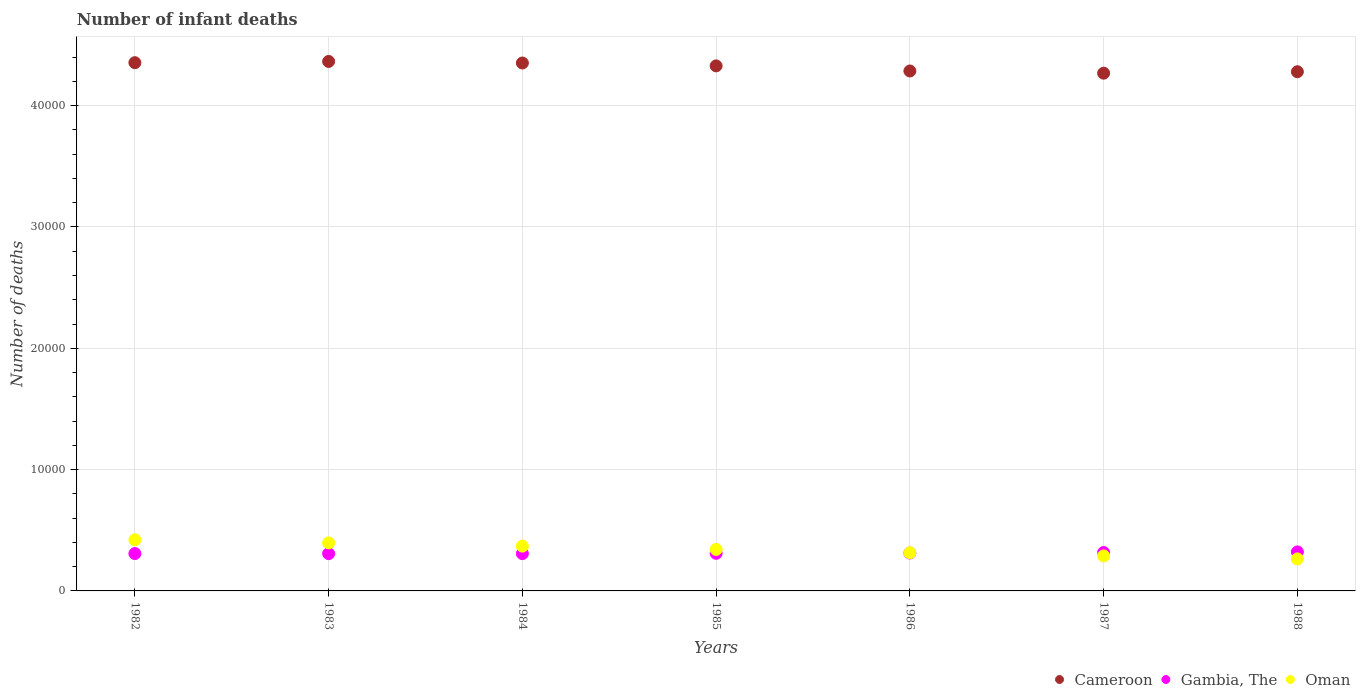What is the number of infant deaths in Oman in 1985?
Make the answer very short. 3419. Across all years, what is the maximum number of infant deaths in Gambia, The?
Your response must be concise. 3215. Across all years, what is the minimum number of infant deaths in Oman?
Your answer should be compact. 2638. What is the total number of infant deaths in Oman in the graph?
Ensure brevity in your answer.  2.40e+04. What is the difference between the number of infant deaths in Oman in 1982 and that in 1984?
Your answer should be compact. 521. What is the difference between the number of infant deaths in Gambia, The in 1984 and the number of infant deaths in Cameroon in 1985?
Offer a terse response. -4.02e+04. What is the average number of infant deaths in Cameroon per year?
Give a very brief answer. 4.32e+04. In the year 1987, what is the difference between the number of infant deaths in Oman and number of infant deaths in Cameroon?
Give a very brief answer. -3.98e+04. What is the ratio of the number of infant deaths in Oman in 1984 to that in 1988?
Give a very brief answer. 1.4. Is the number of infant deaths in Gambia, The in 1983 less than that in 1986?
Offer a very short reply. Yes. Is the difference between the number of infant deaths in Oman in 1987 and 1988 greater than the difference between the number of infant deaths in Cameroon in 1987 and 1988?
Make the answer very short. Yes. What is the difference between the highest and the second highest number of infant deaths in Cameroon?
Keep it short and to the point. 102. What is the difference between the highest and the lowest number of infant deaths in Cameroon?
Your answer should be very brief. 968. In how many years, is the number of infant deaths in Gambia, The greater than the average number of infant deaths in Gambia, The taken over all years?
Provide a short and direct response. 3. Is the sum of the number of infant deaths in Cameroon in 1984 and 1985 greater than the maximum number of infant deaths in Gambia, The across all years?
Your answer should be compact. Yes. Does the number of infant deaths in Gambia, The monotonically increase over the years?
Keep it short and to the point. No. Is the number of infant deaths in Cameroon strictly greater than the number of infant deaths in Oman over the years?
Ensure brevity in your answer.  Yes. What is the difference between two consecutive major ticks on the Y-axis?
Your response must be concise. 10000. Are the values on the major ticks of Y-axis written in scientific E-notation?
Offer a terse response. No. Does the graph contain any zero values?
Give a very brief answer. No. Where does the legend appear in the graph?
Make the answer very short. Bottom right. What is the title of the graph?
Offer a terse response. Number of infant deaths. Does "Curacao" appear as one of the legend labels in the graph?
Provide a succinct answer. No. What is the label or title of the Y-axis?
Give a very brief answer. Number of deaths. What is the Number of deaths of Cameroon in 1982?
Provide a succinct answer. 4.35e+04. What is the Number of deaths of Gambia, The in 1982?
Provide a succinct answer. 3081. What is the Number of deaths in Oman in 1982?
Keep it short and to the point. 4215. What is the Number of deaths in Cameroon in 1983?
Provide a short and direct response. 4.36e+04. What is the Number of deaths of Gambia, The in 1983?
Ensure brevity in your answer.  3073. What is the Number of deaths in Oman in 1983?
Give a very brief answer. 3962. What is the Number of deaths of Cameroon in 1984?
Offer a very short reply. 4.35e+04. What is the Number of deaths of Gambia, The in 1984?
Make the answer very short. 3074. What is the Number of deaths in Oman in 1984?
Offer a terse response. 3694. What is the Number of deaths in Cameroon in 1985?
Make the answer very short. 4.33e+04. What is the Number of deaths in Gambia, The in 1985?
Provide a short and direct response. 3099. What is the Number of deaths of Oman in 1985?
Provide a succinct answer. 3419. What is the Number of deaths in Cameroon in 1986?
Your response must be concise. 4.29e+04. What is the Number of deaths of Gambia, The in 1986?
Make the answer very short. 3123. What is the Number of deaths of Oman in 1986?
Your answer should be very brief. 3146. What is the Number of deaths in Cameroon in 1987?
Provide a succinct answer. 4.27e+04. What is the Number of deaths in Gambia, The in 1987?
Your answer should be compact. 3163. What is the Number of deaths of Oman in 1987?
Make the answer very short. 2885. What is the Number of deaths of Cameroon in 1988?
Offer a very short reply. 4.28e+04. What is the Number of deaths in Gambia, The in 1988?
Provide a succinct answer. 3215. What is the Number of deaths in Oman in 1988?
Your response must be concise. 2638. Across all years, what is the maximum Number of deaths in Cameroon?
Your answer should be very brief. 4.36e+04. Across all years, what is the maximum Number of deaths in Gambia, The?
Provide a succinct answer. 3215. Across all years, what is the maximum Number of deaths of Oman?
Offer a very short reply. 4215. Across all years, what is the minimum Number of deaths of Cameroon?
Make the answer very short. 4.27e+04. Across all years, what is the minimum Number of deaths in Gambia, The?
Your answer should be very brief. 3073. Across all years, what is the minimum Number of deaths of Oman?
Keep it short and to the point. 2638. What is the total Number of deaths in Cameroon in the graph?
Your answer should be compact. 3.02e+05. What is the total Number of deaths in Gambia, The in the graph?
Give a very brief answer. 2.18e+04. What is the total Number of deaths in Oman in the graph?
Provide a short and direct response. 2.40e+04. What is the difference between the Number of deaths in Cameroon in 1982 and that in 1983?
Your answer should be compact. -102. What is the difference between the Number of deaths of Oman in 1982 and that in 1983?
Ensure brevity in your answer.  253. What is the difference between the Number of deaths in Gambia, The in 1982 and that in 1984?
Keep it short and to the point. 7. What is the difference between the Number of deaths in Oman in 1982 and that in 1984?
Your answer should be compact. 521. What is the difference between the Number of deaths of Cameroon in 1982 and that in 1985?
Offer a terse response. 263. What is the difference between the Number of deaths of Oman in 1982 and that in 1985?
Keep it short and to the point. 796. What is the difference between the Number of deaths of Cameroon in 1982 and that in 1986?
Keep it short and to the point. 685. What is the difference between the Number of deaths in Gambia, The in 1982 and that in 1986?
Offer a terse response. -42. What is the difference between the Number of deaths in Oman in 1982 and that in 1986?
Give a very brief answer. 1069. What is the difference between the Number of deaths in Cameroon in 1982 and that in 1987?
Your response must be concise. 866. What is the difference between the Number of deaths of Gambia, The in 1982 and that in 1987?
Your answer should be very brief. -82. What is the difference between the Number of deaths in Oman in 1982 and that in 1987?
Provide a succinct answer. 1330. What is the difference between the Number of deaths of Cameroon in 1982 and that in 1988?
Offer a very short reply. 745. What is the difference between the Number of deaths of Gambia, The in 1982 and that in 1988?
Your answer should be very brief. -134. What is the difference between the Number of deaths in Oman in 1982 and that in 1988?
Give a very brief answer. 1577. What is the difference between the Number of deaths in Cameroon in 1983 and that in 1984?
Your answer should be very brief. 128. What is the difference between the Number of deaths in Gambia, The in 1983 and that in 1984?
Give a very brief answer. -1. What is the difference between the Number of deaths in Oman in 1983 and that in 1984?
Keep it short and to the point. 268. What is the difference between the Number of deaths of Cameroon in 1983 and that in 1985?
Ensure brevity in your answer.  365. What is the difference between the Number of deaths in Oman in 1983 and that in 1985?
Offer a terse response. 543. What is the difference between the Number of deaths of Cameroon in 1983 and that in 1986?
Offer a terse response. 787. What is the difference between the Number of deaths of Gambia, The in 1983 and that in 1986?
Offer a terse response. -50. What is the difference between the Number of deaths in Oman in 1983 and that in 1986?
Your response must be concise. 816. What is the difference between the Number of deaths of Cameroon in 1983 and that in 1987?
Ensure brevity in your answer.  968. What is the difference between the Number of deaths of Gambia, The in 1983 and that in 1987?
Keep it short and to the point. -90. What is the difference between the Number of deaths of Oman in 1983 and that in 1987?
Ensure brevity in your answer.  1077. What is the difference between the Number of deaths of Cameroon in 1983 and that in 1988?
Give a very brief answer. 847. What is the difference between the Number of deaths in Gambia, The in 1983 and that in 1988?
Make the answer very short. -142. What is the difference between the Number of deaths of Oman in 1983 and that in 1988?
Provide a succinct answer. 1324. What is the difference between the Number of deaths of Cameroon in 1984 and that in 1985?
Give a very brief answer. 237. What is the difference between the Number of deaths in Oman in 1984 and that in 1985?
Make the answer very short. 275. What is the difference between the Number of deaths in Cameroon in 1984 and that in 1986?
Your answer should be compact. 659. What is the difference between the Number of deaths in Gambia, The in 1984 and that in 1986?
Your answer should be very brief. -49. What is the difference between the Number of deaths of Oman in 1984 and that in 1986?
Your response must be concise. 548. What is the difference between the Number of deaths in Cameroon in 1984 and that in 1987?
Keep it short and to the point. 840. What is the difference between the Number of deaths of Gambia, The in 1984 and that in 1987?
Give a very brief answer. -89. What is the difference between the Number of deaths in Oman in 1984 and that in 1987?
Offer a terse response. 809. What is the difference between the Number of deaths of Cameroon in 1984 and that in 1988?
Offer a very short reply. 719. What is the difference between the Number of deaths of Gambia, The in 1984 and that in 1988?
Your response must be concise. -141. What is the difference between the Number of deaths of Oman in 1984 and that in 1988?
Keep it short and to the point. 1056. What is the difference between the Number of deaths of Cameroon in 1985 and that in 1986?
Offer a terse response. 422. What is the difference between the Number of deaths in Oman in 1985 and that in 1986?
Your response must be concise. 273. What is the difference between the Number of deaths of Cameroon in 1985 and that in 1987?
Your answer should be compact. 603. What is the difference between the Number of deaths in Gambia, The in 1985 and that in 1987?
Offer a terse response. -64. What is the difference between the Number of deaths of Oman in 1985 and that in 1987?
Offer a terse response. 534. What is the difference between the Number of deaths of Cameroon in 1985 and that in 1988?
Your answer should be compact. 482. What is the difference between the Number of deaths in Gambia, The in 1985 and that in 1988?
Offer a very short reply. -116. What is the difference between the Number of deaths in Oman in 1985 and that in 1988?
Give a very brief answer. 781. What is the difference between the Number of deaths of Cameroon in 1986 and that in 1987?
Your response must be concise. 181. What is the difference between the Number of deaths of Gambia, The in 1986 and that in 1987?
Offer a very short reply. -40. What is the difference between the Number of deaths of Oman in 1986 and that in 1987?
Provide a short and direct response. 261. What is the difference between the Number of deaths of Gambia, The in 1986 and that in 1988?
Provide a short and direct response. -92. What is the difference between the Number of deaths in Oman in 1986 and that in 1988?
Offer a terse response. 508. What is the difference between the Number of deaths of Cameroon in 1987 and that in 1988?
Your answer should be very brief. -121. What is the difference between the Number of deaths in Gambia, The in 1987 and that in 1988?
Offer a terse response. -52. What is the difference between the Number of deaths of Oman in 1987 and that in 1988?
Ensure brevity in your answer.  247. What is the difference between the Number of deaths in Cameroon in 1982 and the Number of deaths in Gambia, The in 1983?
Your response must be concise. 4.05e+04. What is the difference between the Number of deaths in Cameroon in 1982 and the Number of deaths in Oman in 1983?
Ensure brevity in your answer.  3.96e+04. What is the difference between the Number of deaths of Gambia, The in 1982 and the Number of deaths of Oman in 1983?
Your answer should be compact. -881. What is the difference between the Number of deaths of Cameroon in 1982 and the Number of deaths of Gambia, The in 1984?
Your answer should be very brief. 4.05e+04. What is the difference between the Number of deaths of Cameroon in 1982 and the Number of deaths of Oman in 1984?
Ensure brevity in your answer.  3.99e+04. What is the difference between the Number of deaths of Gambia, The in 1982 and the Number of deaths of Oman in 1984?
Your answer should be compact. -613. What is the difference between the Number of deaths of Cameroon in 1982 and the Number of deaths of Gambia, The in 1985?
Ensure brevity in your answer.  4.04e+04. What is the difference between the Number of deaths of Cameroon in 1982 and the Number of deaths of Oman in 1985?
Your response must be concise. 4.01e+04. What is the difference between the Number of deaths in Gambia, The in 1982 and the Number of deaths in Oman in 1985?
Your answer should be very brief. -338. What is the difference between the Number of deaths in Cameroon in 1982 and the Number of deaths in Gambia, The in 1986?
Your answer should be compact. 4.04e+04. What is the difference between the Number of deaths in Cameroon in 1982 and the Number of deaths in Oman in 1986?
Your response must be concise. 4.04e+04. What is the difference between the Number of deaths in Gambia, The in 1982 and the Number of deaths in Oman in 1986?
Your answer should be very brief. -65. What is the difference between the Number of deaths of Cameroon in 1982 and the Number of deaths of Gambia, The in 1987?
Give a very brief answer. 4.04e+04. What is the difference between the Number of deaths in Cameroon in 1982 and the Number of deaths in Oman in 1987?
Make the answer very short. 4.07e+04. What is the difference between the Number of deaths of Gambia, The in 1982 and the Number of deaths of Oman in 1987?
Provide a succinct answer. 196. What is the difference between the Number of deaths of Cameroon in 1982 and the Number of deaths of Gambia, The in 1988?
Your response must be concise. 4.03e+04. What is the difference between the Number of deaths in Cameroon in 1982 and the Number of deaths in Oman in 1988?
Keep it short and to the point. 4.09e+04. What is the difference between the Number of deaths of Gambia, The in 1982 and the Number of deaths of Oman in 1988?
Give a very brief answer. 443. What is the difference between the Number of deaths of Cameroon in 1983 and the Number of deaths of Gambia, The in 1984?
Provide a succinct answer. 4.06e+04. What is the difference between the Number of deaths of Cameroon in 1983 and the Number of deaths of Oman in 1984?
Your response must be concise. 4.00e+04. What is the difference between the Number of deaths in Gambia, The in 1983 and the Number of deaths in Oman in 1984?
Make the answer very short. -621. What is the difference between the Number of deaths in Cameroon in 1983 and the Number of deaths in Gambia, The in 1985?
Make the answer very short. 4.05e+04. What is the difference between the Number of deaths in Cameroon in 1983 and the Number of deaths in Oman in 1985?
Your answer should be very brief. 4.02e+04. What is the difference between the Number of deaths in Gambia, The in 1983 and the Number of deaths in Oman in 1985?
Provide a short and direct response. -346. What is the difference between the Number of deaths in Cameroon in 1983 and the Number of deaths in Gambia, The in 1986?
Make the answer very short. 4.05e+04. What is the difference between the Number of deaths in Cameroon in 1983 and the Number of deaths in Oman in 1986?
Ensure brevity in your answer.  4.05e+04. What is the difference between the Number of deaths in Gambia, The in 1983 and the Number of deaths in Oman in 1986?
Offer a very short reply. -73. What is the difference between the Number of deaths of Cameroon in 1983 and the Number of deaths of Gambia, The in 1987?
Provide a short and direct response. 4.05e+04. What is the difference between the Number of deaths of Cameroon in 1983 and the Number of deaths of Oman in 1987?
Provide a short and direct response. 4.08e+04. What is the difference between the Number of deaths in Gambia, The in 1983 and the Number of deaths in Oman in 1987?
Make the answer very short. 188. What is the difference between the Number of deaths in Cameroon in 1983 and the Number of deaths in Gambia, The in 1988?
Your response must be concise. 4.04e+04. What is the difference between the Number of deaths of Cameroon in 1983 and the Number of deaths of Oman in 1988?
Offer a very short reply. 4.10e+04. What is the difference between the Number of deaths in Gambia, The in 1983 and the Number of deaths in Oman in 1988?
Make the answer very short. 435. What is the difference between the Number of deaths of Cameroon in 1984 and the Number of deaths of Gambia, The in 1985?
Provide a succinct answer. 4.04e+04. What is the difference between the Number of deaths of Cameroon in 1984 and the Number of deaths of Oman in 1985?
Offer a terse response. 4.01e+04. What is the difference between the Number of deaths of Gambia, The in 1984 and the Number of deaths of Oman in 1985?
Offer a very short reply. -345. What is the difference between the Number of deaths of Cameroon in 1984 and the Number of deaths of Gambia, The in 1986?
Ensure brevity in your answer.  4.04e+04. What is the difference between the Number of deaths in Cameroon in 1984 and the Number of deaths in Oman in 1986?
Provide a succinct answer. 4.04e+04. What is the difference between the Number of deaths of Gambia, The in 1984 and the Number of deaths of Oman in 1986?
Keep it short and to the point. -72. What is the difference between the Number of deaths of Cameroon in 1984 and the Number of deaths of Gambia, The in 1987?
Provide a succinct answer. 4.04e+04. What is the difference between the Number of deaths in Cameroon in 1984 and the Number of deaths in Oman in 1987?
Provide a short and direct response. 4.06e+04. What is the difference between the Number of deaths in Gambia, The in 1984 and the Number of deaths in Oman in 1987?
Give a very brief answer. 189. What is the difference between the Number of deaths of Cameroon in 1984 and the Number of deaths of Gambia, The in 1988?
Offer a very short reply. 4.03e+04. What is the difference between the Number of deaths in Cameroon in 1984 and the Number of deaths in Oman in 1988?
Offer a very short reply. 4.09e+04. What is the difference between the Number of deaths of Gambia, The in 1984 and the Number of deaths of Oman in 1988?
Offer a very short reply. 436. What is the difference between the Number of deaths in Cameroon in 1985 and the Number of deaths in Gambia, The in 1986?
Provide a succinct answer. 4.02e+04. What is the difference between the Number of deaths in Cameroon in 1985 and the Number of deaths in Oman in 1986?
Make the answer very short. 4.01e+04. What is the difference between the Number of deaths of Gambia, The in 1985 and the Number of deaths of Oman in 1986?
Make the answer very short. -47. What is the difference between the Number of deaths of Cameroon in 1985 and the Number of deaths of Gambia, The in 1987?
Give a very brief answer. 4.01e+04. What is the difference between the Number of deaths of Cameroon in 1985 and the Number of deaths of Oman in 1987?
Make the answer very short. 4.04e+04. What is the difference between the Number of deaths of Gambia, The in 1985 and the Number of deaths of Oman in 1987?
Your answer should be compact. 214. What is the difference between the Number of deaths in Cameroon in 1985 and the Number of deaths in Gambia, The in 1988?
Keep it short and to the point. 4.01e+04. What is the difference between the Number of deaths in Cameroon in 1985 and the Number of deaths in Oman in 1988?
Make the answer very short. 4.06e+04. What is the difference between the Number of deaths of Gambia, The in 1985 and the Number of deaths of Oman in 1988?
Offer a very short reply. 461. What is the difference between the Number of deaths of Cameroon in 1986 and the Number of deaths of Gambia, The in 1987?
Provide a succinct answer. 3.97e+04. What is the difference between the Number of deaths of Cameroon in 1986 and the Number of deaths of Oman in 1987?
Keep it short and to the point. 4.00e+04. What is the difference between the Number of deaths of Gambia, The in 1986 and the Number of deaths of Oman in 1987?
Your answer should be very brief. 238. What is the difference between the Number of deaths of Cameroon in 1986 and the Number of deaths of Gambia, The in 1988?
Your response must be concise. 3.96e+04. What is the difference between the Number of deaths in Cameroon in 1986 and the Number of deaths in Oman in 1988?
Offer a very short reply. 4.02e+04. What is the difference between the Number of deaths in Gambia, The in 1986 and the Number of deaths in Oman in 1988?
Your response must be concise. 485. What is the difference between the Number of deaths of Cameroon in 1987 and the Number of deaths of Gambia, The in 1988?
Ensure brevity in your answer.  3.95e+04. What is the difference between the Number of deaths of Cameroon in 1987 and the Number of deaths of Oman in 1988?
Provide a short and direct response. 4.00e+04. What is the difference between the Number of deaths in Gambia, The in 1987 and the Number of deaths in Oman in 1988?
Your answer should be very brief. 525. What is the average Number of deaths of Cameroon per year?
Your response must be concise. 4.32e+04. What is the average Number of deaths of Gambia, The per year?
Provide a succinct answer. 3118.29. What is the average Number of deaths in Oman per year?
Give a very brief answer. 3422.71. In the year 1982, what is the difference between the Number of deaths in Cameroon and Number of deaths in Gambia, The?
Make the answer very short. 4.05e+04. In the year 1982, what is the difference between the Number of deaths in Cameroon and Number of deaths in Oman?
Ensure brevity in your answer.  3.93e+04. In the year 1982, what is the difference between the Number of deaths of Gambia, The and Number of deaths of Oman?
Ensure brevity in your answer.  -1134. In the year 1983, what is the difference between the Number of deaths of Cameroon and Number of deaths of Gambia, The?
Provide a short and direct response. 4.06e+04. In the year 1983, what is the difference between the Number of deaths in Cameroon and Number of deaths in Oman?
Offer a very short reply. 3.97e+04. In the year 1983, what is the difference between the Number of deaths in Gambia, The and Number of deaths in Oman?
Your answer should be very brief. -889. In the year 1984, what is the difference between the Number of deaths of Cameroon and Number of deaths of Gambia, The?
Give a very brief answer. 4.04e+04. In the year 1984, what is the difference between the Number of deaths in Cameroon and Number of deaths in Oman?
Your answer should be very brief. 3.98e+04. In the year 1984, what is the difference between the Number of deaths of Gambia, The and Number of deaths of Oman?
Your answer should be very brief. -620. In the year 1985, what is the difference between the Number of deaths in Cameroon and Number of deaths in Gambia, The?
Provide a short and direct response. 4.02e+04. In the year 1985, what is the difference between the Number of deaths in Cameroon and Number of deaths in Oman?
Your answer should be compact. 3.99e+04. In the year 1985, what is the difference between the Number of deaths in Gambia, The and Number of deaths in Oman?
Ensure brevity in your answer.  -320. In the year 1986, what is the difference between the Number of deaths in Cameroon and Number of deaths in Gambia, The?
Provide a succinct answer. 3.97e+04. In the year 1986, what is the difference between the Number of deaths in Cameroon and Number of deaths in Oman?
Give a very brief answer. 3.97e+04. In the year 1986, what is the difference between the Number of deaths of Gambia, The and Number of deaths of Oman?
Give a very brief answer. -23. In the year 1987, what is the difference between the Number of deaths in Cameroon and Number of deaths in Gambia, The?
Offer a very short reply. 3.95e+04. In the year 1987, what is the difference between the Number of deaths in Cameroon and Number of deaths in Oman?
Provide a succinct answer. 3.98e+04. In the year 1987, what is the difference between the Number of deaths in Gambia, The and Number of deaths in Oman?
Ensure brevity in your answer.  278. In the year 1988, what is the difference between the Number of deaths in Cameroon and Number of deaths in Gambia, The?
Provide a short and direct response. 3.96e+04. In the year 1988, what is the difference between the Number of deaths of Cameroon and Number of deaths of Oman?
Offer a very short reply. 4.02e+04. In the year 1988, what is the difference between the Number of deaths in Gambia, The and Number of deaths in Oman?
Ensure brevity in your answer.  577. What is the ratio of the Number of deaths of Oman in 1982 to that in 1983?
Provide a succinct answer. 1.06. What is the ratio of the Number of deaths in Cameroon in 1982 to that in 1984?
Offer a terse response. 1. What is the ratio of the Number of deaths in Gambia, The in 1982 to that in 1984?
Give a very brief answer. 1. What is the ratio of the Number of deaths of Oman in 1982 to that in 1984?
Give a very brief answer. 1.14. What is the ratio of the Number of deaths of Cameroon in 1982 to that in 1985?
Give a very brief answer. 1.01. What is the ratio of the Number of deaths of Oman in 1982 to that in 1985?
Your answer should be very brief. 1.23. What is the ratio of the Number of deaths in Gambia, The in 1982 to that in 1986?
Offer a terse response. 0.99. What is the ratio of the Number of deaths of Oman in 1982 to that in 1986?
Provide a short and direct response. 1.34. What is the ratio of the Number of deaths of Cameroon in 1982 to that in 1987?
Make the answer very short. 1.02. What is the ratio of the Number of deaths of Gambia, The in 1982 to that in 1987?
Your answer should be very brief. 0.97. What is the ratio of the Number of deaths of Oman in 1982 to that in 1987?
Keep it short and to the point. 1.46. What is the ratio of the Number of deaths of Cameroon in 1982 to that in 1988?
Your answer should be very brief. 1.02. What is the ratio of the Number of deaths in Gambia, The in 1982 to that in 1988?
Offer a terse response. 0.96. What is the ratio of the Number of deaths in Oman in 1982 to that in 1988?
Your answer should be compact. 1.6. What is the ratio of the Number of deaths of Oman in 1983 to that in 1984?
Ensure brevity in your answer.  1.07. What is the ratio of the Number of deaths of Cameroon in 1983 to that in 1985?
Provide a succinct answer. 1.01. What is the ratio of the Number of deaths of Gambia, The in 1983 to that in 1985?
Your answer should be compact. 0.99. What is the ratio of the Number of deaths of Oman in 1983 to that in 1985?
Keep it short and to the point. 1.16. What is the ratio of the Number of deaths of Cameroon in 1983 to that in 1986?
Offer a very short reply. 1.02. What is the ratio of the Number of deaths in Oman in 1983 to that in 1986?
Provide a succinct answer. 1.26. What is the ratio of the Number of deaths of Cameroon in 1983 to that in 1987?
Your answer should be compact. 1.02. What is the ratio of the Number of deaths of Gambia, The in 1983 to that in 1987?
Ensure brevity in your answer.  0.97. What is the ratio of the Number of deaths of Oman in 1983 to that in 1987?
Offer a very short reply. 1.37. What is the ratio of the Number of deaths of Cameroon in 1983 to that in 1988?
Keep it short and to the point. 1.02. What is the ratio of the Number of deaths of Gambia, The in 1983 to that in 1988?
Give a very brief answer. 0.96. What is the ratio of the Number of deaths in Oman in 1983 to that in 1988?
Ensure brevity in your answer.  1.5. What is the ratio of the Number of deaths in Cameroon in 1984 to that in 1985?
Provide a succinct answer. 1.01. What is the ratio of the Number of deaths of Oman in 1984 to that in 1985?
Provide a succinct answer. 1.08. What is the ratio of the Number of deaths in Cameroon in 1984 to that in 1986?
Give a very brief answer. 1.02. What is the ratio of the Number of deaths of Gambia, The in 1984 to that in 1986?
Your response must be concise. 0.98. What is the ratio of the Number of deaths in Oman in 1984 to that in 1986?
Ensure brevity in your answer.  1.17. What is the ratio of the Number of deaths of Cameroon in 1984 to that in 1987?
Ensure brevity in your answer.  1.02. What is the ratio of the Number of deaths of Gambia, The in 1984 to that in 1987?
Ensure brevity in your answer.  0.97. What is the ratio of the Number of deaths of Oman in 1984 to that in 1987?
Give a very brief answer. 1.28. What is the ratio of the Number of deaths in Cameroon in 1984 to that in 1988?
Provide a short and direct response. 1.02. What is the ratio of the Number of deaths of Gambia, The in 1984 to that in 1988?
Ensure brevity in your answer.  0.96. What is the ratio of the Number of deaths in Oman in 1984 to that in 1988?
Your answer should be very brief. 1.4. What is the ratio of the Number of deaths in Cameroon in 1985 to that in 1986?
Offer a terse response. 1.01. What is the ratio of the Number of deaths of Oman in 1985 to that in 1986?
Keep it short and to the point. 1.09. What is the ratio of the Number of deaths of Cameroon in 1985 to that in 1987?
Your answer should be compact. 1.01. What is the ratio of the Number of deaths in Gambia, The in 1985 to that in 1987?
Give a very brief answer. 0.98. What is the ratio of the Number of deaths of Oman in 1985 to that in 1987?
Offer a terse response. 1.19. What is the ratio of the Number of deaths in Cameroon in 1985 to that in 1988?
Offer a very short reply. 1.01. What is the ratio of the Number of deaths in Gambia, The in 1985 to that in 1988?
Provide a succinct answer. 0.96. What is the ratio of the Number of deaths in Oman in 1985 to that in 1988?
Your answer should be compact. 1.3. What is the ratio of the Number of deaths of Gambia, The in 1986 to that in 1987?
Keep it short and to the point. 0.99. What is the ratio of the Number of deaths in Oman in 1986 to that in 1987?
Provide a succinct answer. 1.09. What is the ratio of the Number of deaths of Gambia, The in 1986 to that in 1988?
Offer a very short reply. 0.97. What is the ratio of the Number of deaths in Oman in 1986 to that in 1988?
Give a very brief answer. 1.19. What is the ratio of the Number of deaths of Cameroon in 1987 to that in 1988?
Make the answer very short. 1. What is the ratio of the Number of deaths of Gambia, The in 1987 to that in 1988?
Ensure brevity in your answer.  0.98. What is the ratio of the Number of deaths in Oman in 1987 to that in 1988?
Your answer should be very brief. 1.09. What is the difference between the highest and the second highest Number of deaths in Cameroon?
Offer a very short reply. 102. What is the difference between the highest and the second highest Number of deaths of Oman?
Your response must be concise. 253. What is the difference between the highest and the lowest Number of deaths of Cameroon?
Offer a very short reply. 968. What is the difference between the highest and the lowest Number of deaths of Gambia, The?
Offer a very short reply. 142. What is the difference between the highest and the lowest Number of deaths of Oman?
Give a very brief answer. 1577. 